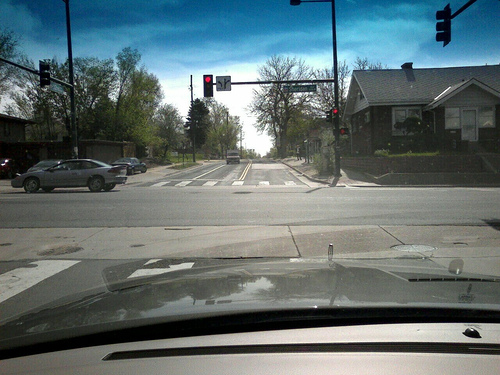What is the weather like in the image? The weather appears to be clear with a bright blue sky and ample sunlight, suggesting a fine day with good visibility. 